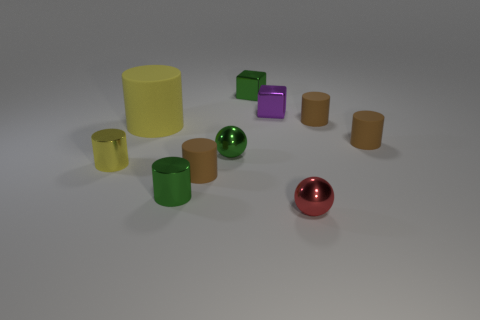How many brown cylinders must be subtracted to get 1 brown cylinders? 2 Subtract all brown cylinders. How many cylinders are left? 3 Subtract all large matte cylinders. How many cylinders are left? 5 Subtract all cylinders. How many objects are left? 4 Subtract all gray cylinders. How many gray balls are left? 0 Subtract all small green metallic spheres. Subtract all metallic objects. How many objects are left? 3 Add 1 tiny red metal things. How many tiny red metal things are left? 2 Add 3 red objects. How many red objects exist? 4 Subtract 0 purple cylinders. How many objects are left? 10 Subtract 2 spheres. How many spheres are left? 0 